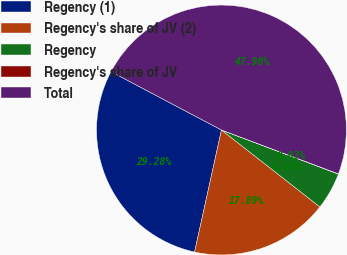Convert chart to OTSL. <chart><loc_0><loc_0><loc_500><loc_500><pie_chart><fcel>Regency (1)<fcel>Regency's share of JV (2)<fcel>Regency<fcel>Regency's share of JV<fcel>Total<nl><fcel>29.28%<fcel>17.89%<fcel>4.82%<fcel>0.03%<fcel>47.98%<nl></chart> 